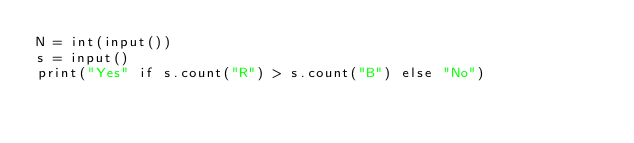Convert code to text. <code><loc_0><loc_0><loc_500><loc_500><_Python_>N = int(input())
s = input()
print("Yes" if s.count("R") > s.count("B") else "No")</code> 